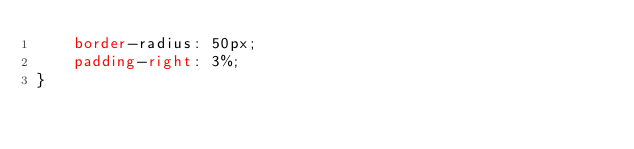Convert code to text. <code><loc_0><loc_0><loc_500><loc_500><_CSS_>    border-radius: 50px;
    padding-right: 3%;
}
</code> 